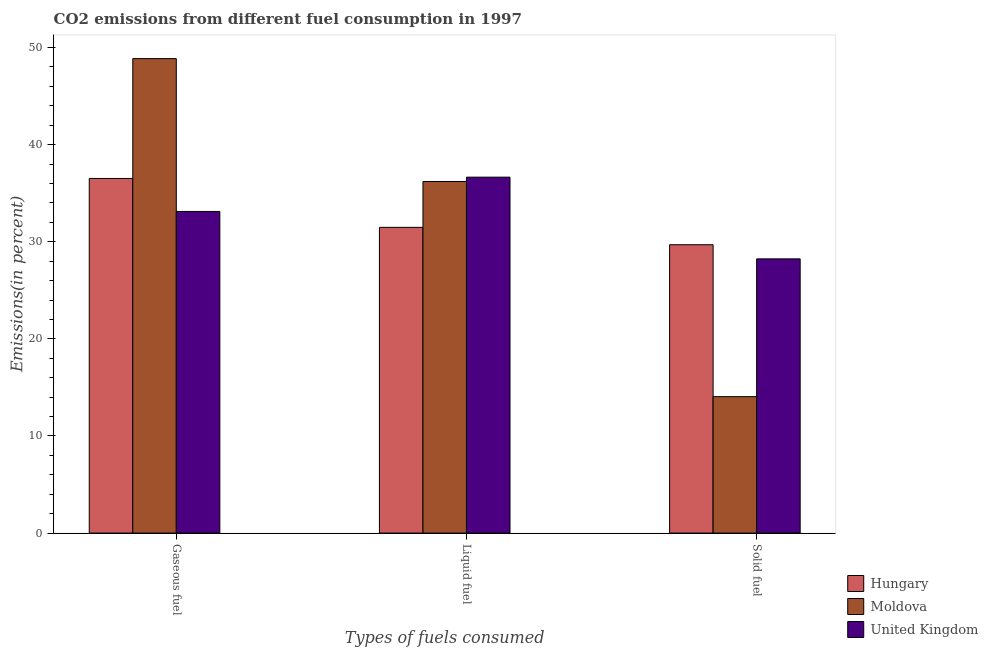How many groups of bars are there?
Provide a short and direct response. 3. Are the number of bars on each tick of the X-axis equal?
Offer a terse response. Yes. What is the label of the 2nd group of bars from the left?
Provide a short and direct response. Liquid fuel. What is the percentage of liquid fuel emission in Hungary?
Ensure brevity in your answer.  31.48. Across all countries, what is the maximum percentage of gaseous fuel emission?
Provide a short and direct response. 48.86. Across all countries, what is the minimum percentage of liquid fuel emission?
Your response must be concise. 31.48. In which country was the percentage of solid fuel emission maximum?
Provide a succinct answer. Hungary. In which country was the percentage of solid fuel emission minimum?
Provide a succinct answer. Moldova. What is the total percentage of solid fuel emission in the graph?
Give a very brief answer. 71.98. What is the difference between the percentage of liquid fuel emission in Hungary and that in Moldova?
Make the answer very short. -4.72. What is the difference between the percentage of solid fuel emission in Hungary and the percentage of liquid fuel emission in United Kingdom?
Your response must be concise. -6.96. What is the average percentage of liquid fuel emission per country?
Offer a terse response. 34.78. What is the difference between the percentage of liquid fuel emission and percentage of gaseous fuel emission in United Kingdom?
Ensure brevity in your answer.  3.53. What is the ratio of the percentage of liquid fuel emission in Hungary to that in United Kingdom?
Give a very brief answer. 0.86. What is the difference between the highest and the second highest percentage of solid fuel emission?
Your response must be concise. 1.46. What is the difference between the highest and the lowest percentage of gaseous fuel emission?
Offer a terse response. 15.74. What does the 1st bar from the left in Liquid fuel represents?
Your response must be concise. Hungary. What does the 1st bar from the right in Solid fuel represents?
Your response must be concise. United Kingdom. Is it the case that in every country, the sum of the percentage of gaseous fuel emission and percentage of liquid fuel emission is greater than the percentage of solid fuel emission?
Your response must be concise. Yes. How many bars are there?
Provide a short and direct response. 9. Are all the bars in the graph horizontal?
Ensure brevity in your answer.  No. How many countries are there in the graph?
Your answer should be compact. 3. Are the values on the major ticks of Y-axis written in scientific E-notation?
Offer a very short reply. No. Does the graph contain any zero values?
Keep it short and to the point. No. Does the graph contain grids?
Your answer should be very brief. No. What is the title of the graph?
Offer a very short reply. CO2 emissions from different fuel consumption in 1997. What is the label or title of the X-axis?
Offer a terse response. Types of fuels consumed. What is the label or title of the Y-axis?
Give a very brief answer. Emissions(in percent). What is the Emissions(in percent) in Hungary in Gaseous fuel?
Your response must be concise. 36.52. What is the Emissions(in percent) of Moldova in Gaseous fuel?
Make the answer very short. 48.86. What is the Emissions(in percent) in United Kingdom in Gaseous fuel?
Offer a very short reply. 33.12. What is the Emissions(in percent) in Hungary in Liquid fuel?
Your response must be concise. 31.48. What is the Emissions(in percent) in Moldova in Liquid fuel?
Provide a succinct answer. 36.21. What is the Emissions(in percent) in United Kingdom in Liquid fuel?
Your answer should be very brief. 36.65. What is the Emissions(in percent) in Hungary in Solid fuel?
Keep it short and to the point. 29.7. What is the Emissions(in percent) in Moldova in Solid fuel?
Your answer should be very brief. 14.05. What is the Emissions(in percent) of United Kingdom in Solid fuel?
Give a very brief answer. 28.24. Across all Types of fuels consumed, what is the maximum Emissions(in percent) of Hungary?
Offer a terse response. 36.52. Across all Types of fuels consumed, what is the maximum Emissions(in percent) of Moldova?
Your answer should be very brief. 48.86. Across all Types of fuels consumed, what is the maximum Emissions(in percent) of United Kingdom?
Your response must be concise. 36.65. Across all Types of fuels consumed, what is the minimum Emissions(in percent) of Hungary?
Your answer should be compact. 29.7. Across all Types of fuels consumed, what is the minimum Emissions(in percent) of Moldova?
Give a very brief answer. 14.05. Across all Types of fuels consumed, what is the minimum Emissions(in percent) in United Kingdom?
Your answer should be very brief. 28.24. What is the total Emissions(in percent) in Hungary in the graph?
Ensure brevity in your answer.  97.7. What is the total Emissions(in percent) of Moldova in the graph?
Your response must be concise. 99.12. What is the total Emissions(in percent) in United Kingdom in the graph?
Ensure brevity in your answer.  98.01. What is the difference between the Emissions(in percent) in Hungary in Gaseous fuel and that in Liquid fuel?
Offer a very short reply. 5.03. What is the difference between the Emissions(in percent) in Moldova in Gaseous fuel and that in Liquid fuel?
Ensure brevity in your answer.  12.65. What is the difference between the Emissions(in percent) in United Kingdom in Gaseous fuel and that in Liquid fuel?
Make the answer very short. -3.53. What is the difference between the Emissions(in percent) in Hungary in Gaseous fuel and that in Solid fuel?
Your response must be concise. 6.82. What is the difference between the Emissions(in percent) in Moldova in Gaseous fuel and that in Solid fuel?
Provide a short and direct response. 34.81. What is the difference between the Emissions(in percent) in United Kingdom in Gaseous fuel and that in Solid fuel?
Ensure brevity in your answer.  4.88. What is the difference between the Emissions(in percent) of Hungary in Liquid fuel and that in Solid fuel?
Keep it short and to the point. 1.79. What is the difference between the Emissions(in percent) of Moldova in Liquid fuel and that in Solid fuel?
Your answer should be very brief. 22.16. What is the difference between the Emissions(in percent) in United Kingdom in Liquid fuel and that in Solid fuel?
Your answer should be compact. 8.41. What is the difference between the Emissions(in percent) of Hungary in Gaseous fuel and the Emissions(in percent) of Moldova in Liquid fuel?
Your answer should be very brief. 0.31. What is the difference between the Emissions(in percent) in Hungary in Gaseous fuel and the Emissions(in percent) in United Kingdom in Liquid fuel?
Ensure brevity in your answer.  -0.13. What is the difference between the Emissions(in percent) of Moldova in Gaseous fuel and the Emissions(in percent) of United Kingdom in Liquid fuel?
Your answer should be very brief. 12.21. What is the difference between the Emissions(in percent) of Hungary in Gaseous fuel and the Emissions(in percent) of Moldova in Solid fuel?
Make the answer very short. 22.47. What is the difference between the Emissions(in percent) in Hungary in Gaseous fuel and the Emissions(in percent) in United Kingdom in Solid fuel?
Make the answer very short. 8.28. What is the difference between the Emissions(in percent) of Moldova in Gaseous fuel and the Emissions(in percent) of United Kingdom in Solid fuel?
Make the answer very short. 20.62. What is the difference between the Emissions(in percent) in Hungary in Liquid fuel and the Emissions(in percent) in Moldova in Solid fuel?
Your response must be concise. 17.43. What is the difference between the Emissions(in percent) of Hungary in Liquid fuel and the Emissions(in percent) of United Kingdom in Solid fuel?
Make the answer very short. 3.25. What is the difference between the Emissions(in percent) in Moldova in Liquid fuel and the Emissions(in percent) in United Kingdom in Solid fuel?
Your answer should be very brief. 7.97. What is the average Emissions(in percent) of Hungary per Types of fuels consumed?
Keep it short and to the point. 32.57. What is the average Emissions(in percent) in Moldova per Types of fuels consumed?
Keep it short and to the point. 33.04. What is the average Emissions(in percent) of United Kingdom per Types of fuels consumed?
Offer a very short reply. 32.67. What is the difference between the Emissions(in percent) in Hungary and Emissions(in percent) in Moldova in Gaseous fuel?
Offer a very short reply. -12.34. What is the difference between the Emissions(in percent) of Hungary and Emissions(in percent) of United Kingdom in Gaseous fuel?
Provide a short and direct response. 3.4. What is the difference between the Emissions(in percent) of Moldova and Emissions(in percent) of United Kingdom in Gaseous fuel?
Give a very brief answer. 15.74. What is the difference between the Emissions(in percent) of Hungary and Emissions(in percent) of Moldova in Liquid fuel?
Offer a terse response. -4.72. What is the difference between the Emissions(in percent) in Hungary and Emissions(in percent) in United Kingdom in Liquid fuel?
Your answer should be very brief. -5.17. What is the difference between the Emissions(in percent) in Moldova and Emissions(in percent) in United Kingdom in Liquid fuel?
Ensure brevity in your answer.  -0.44. What is the difference between the Emissions(in percent) in Hungary and Emissions(in percent) in Moldova in Solid fuel?
Ensure brevity in your answer.  15.65. What is the difference between the Emissions(in percent) of Hungary and Emissions(in percent) of United Kingdom in Solid fuel?
Offer a terse response. 1.46. What is the difference between the Emissions(in percent) of Moldova and Emissions(in percent) of United Kingdom in Solid fuel?
Give a very brief answer. -14.19. What is the ratio of the Emissions(in percent) of Hungary in Gaseous fuel to that in Liquid fuel?
Offer a very short reply. 1.16. What is the ratio of the Emissions(in percent) in Moldova in Gaseous fuel to that in Liquid fuel?
Make the answer very short. 1.35. What is the ratio of the Emissions(in percent) in United Kingdom in Gaseous fuel to that in Liquid fuel?
Ensure brevity in your answer.  0.9. What is the ratio of the Emissions(in percent) of Hungary in Gaseous fuel to that in Solid fuel?
Ensure brevity in your answer.  1.23. What is the ratio of the Emissions(in percent) in Moldova in Gaseous fuel to that in Solid fuel?
Make the answer very short. 3.48. What is the ratio of the Emissions(in percent) in United Kingdom in Gaseous fuel to that in Solid fuel?
Your answer should be compact. 1.17. What is the ratio of the Emissions(in percent) of Hungary in Liquid fuel to that in Solid fuel?
Give a very brief answer. 1.06. What is the ratio of the Emissions(in percent) in Moldova in Liquid fuel to that in Solid fuel?
Your response must be concise. 2.58. What is the ratio of the Emissions(in percent) in United Kingdom in Liquid fuel to that in Solid fuel?
Your answer should be very brief. 1.3. What is the difference between the highest and the second highest Emissions(in percent) of Hungary?
Ensure brevity in your answer.  5.03. What is the difference between the highest and the second highest Emissions(in percent) in Moldova?
Offer a terse response. 12.65. What is the difference between the highest and the second highest Emissions(in percent) of United Kingdom?
Offer a very short reply. 3.53. What is the difference between the highest and the lowest Emissions(in percent) in Hungary?
Make the answer very short. 6.82. What is the difference between the highest and the lowest Emissions(in percent) of Moldova?
Your answer should be compact. 34.81. What is the difference between the highest and the lowest Emissions(in percent) in United Kingdom?
Provide a short and direct response. 8.41. 